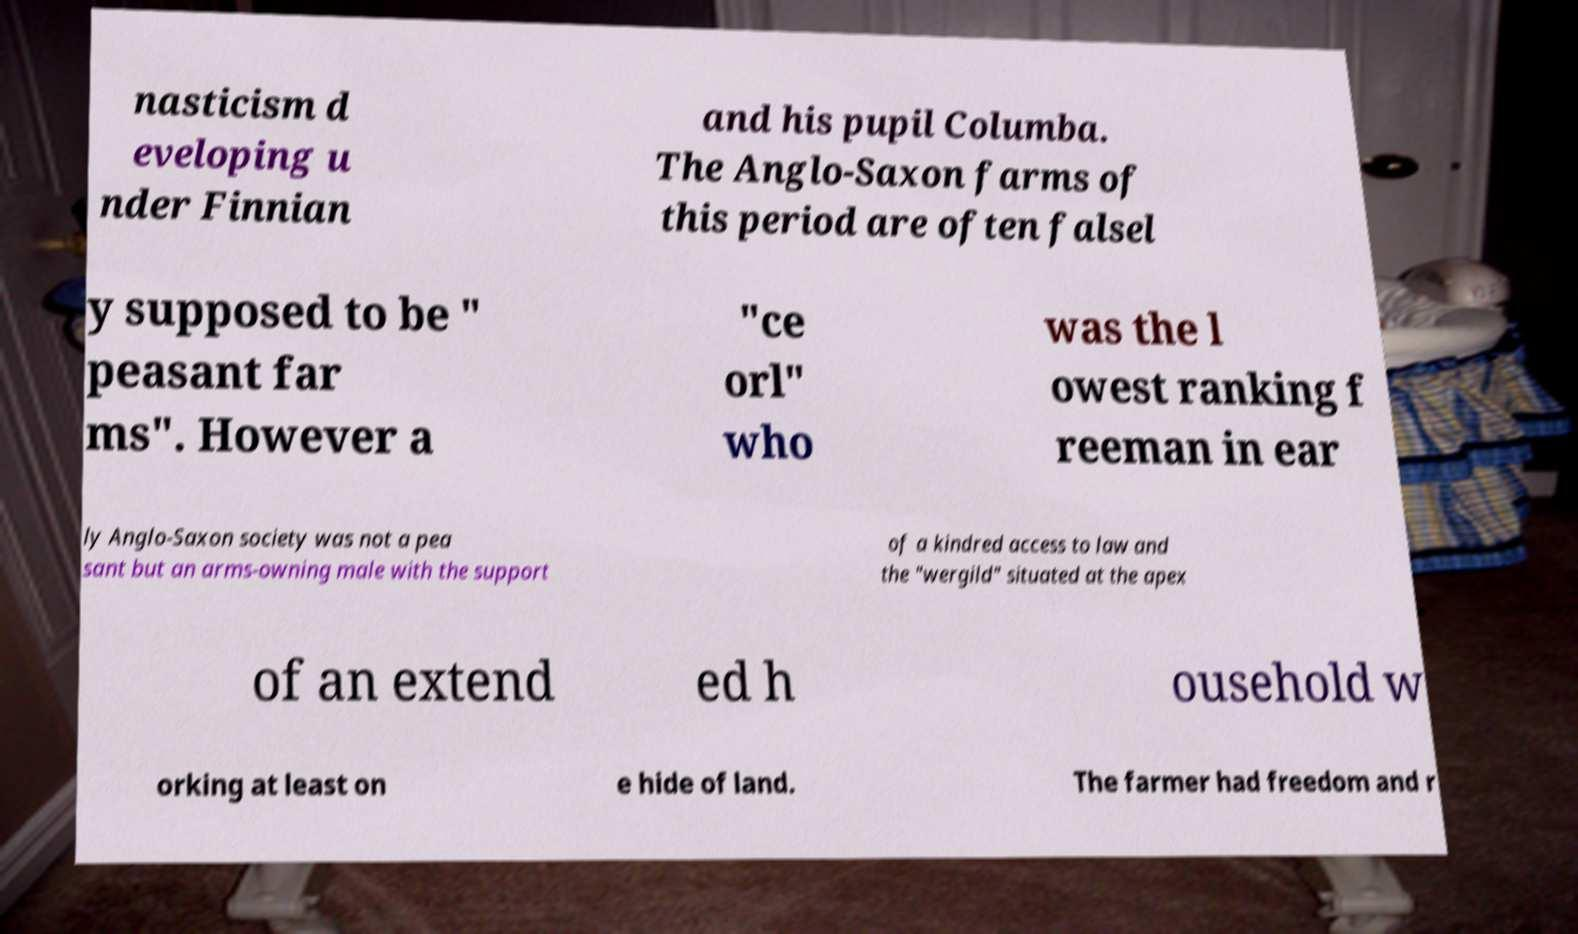Can you accurately transcribe the text from the provided image for me? nasticism d eveloping u nder Finnian and his pupil Columba. The Anglo-Saxon farms of this period are often falsel y supposed to be " peasant far ms". However a "ce orl" who was the l owest ranking f reeman in ear ly Anglo-Saxon society was not a pea sant but an arms-owning male with the support of a kindred access to law and the "wergild" situated at the apex of an extend ed h ousehold w orking at least on e hide of land. The farmer had freedom and r 